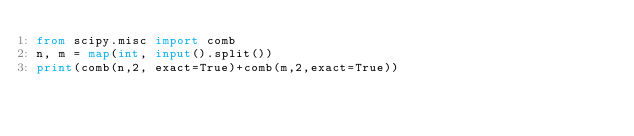<code> <loc_0><loc_0><loc_500><loc_500><_Python_>from scipy.misc import comb
n, m = map(int, input().split())
print(comb(n,2, exact=True)+comb(m,2,exact=True))</code> 